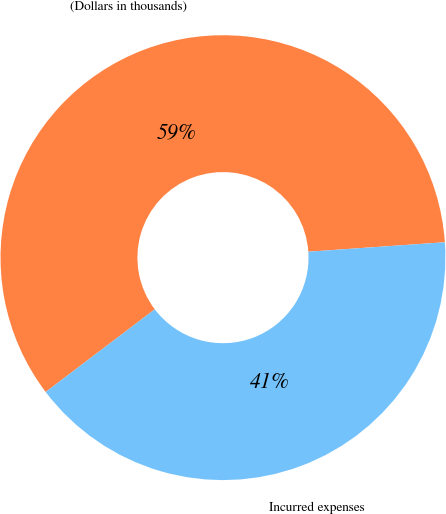<chart> <loc_0><loc_0><loc_500><loc_500><pie_chart><fcel>(Dollars in thousands)<fcel>Incurred expenses<nl><fcel>59.22%<fcel>40.78%<nl></chart> 